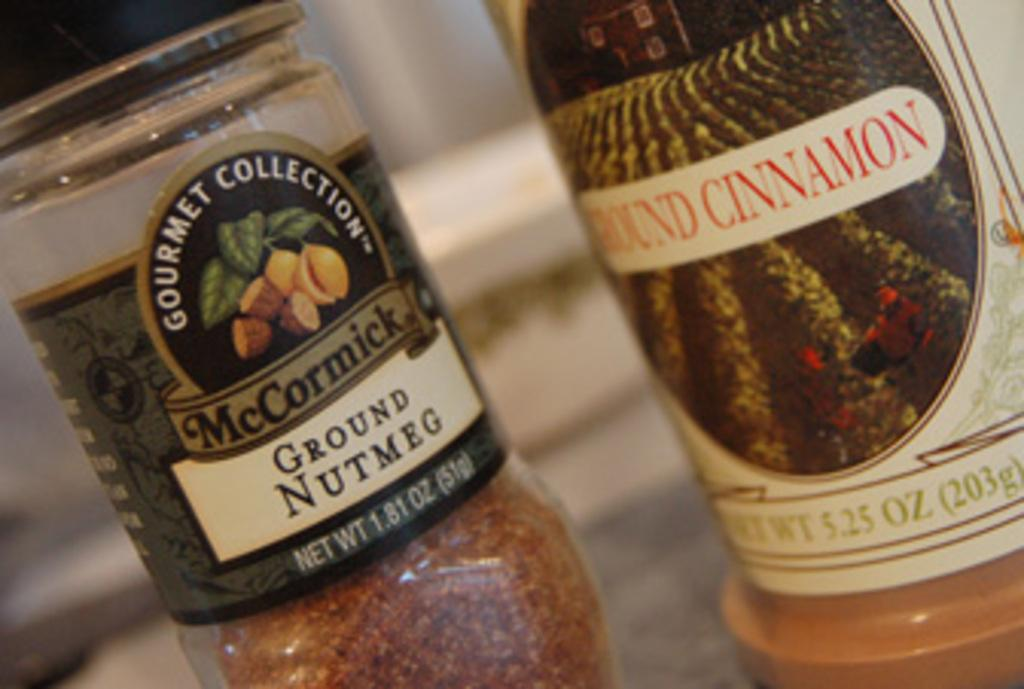Provide a one-sentence caption for the provided image. A ground nutmeg bottle sits next to a ground cinnamon bottle. 